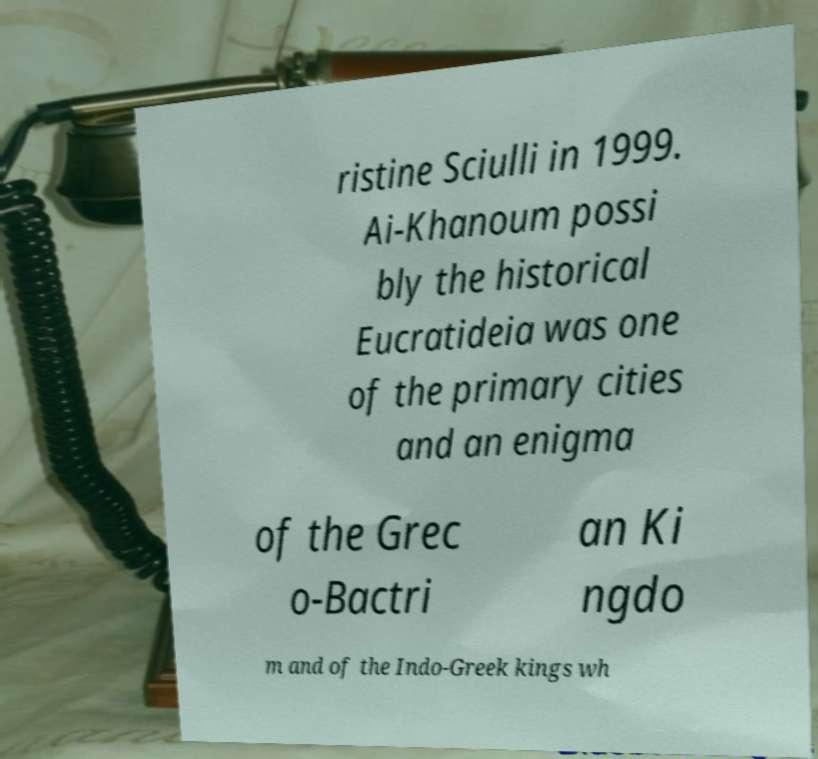Could you assist in decoding the text presented in this image and type it out clearly? ristine Sciulli in 1999. Ai-Khanoum possi bly the historical Eucratideia was one of the primary cities and an enigma of the Grec o-Bactri an Ki ngdo m and of the Indo-Greek kings wh 